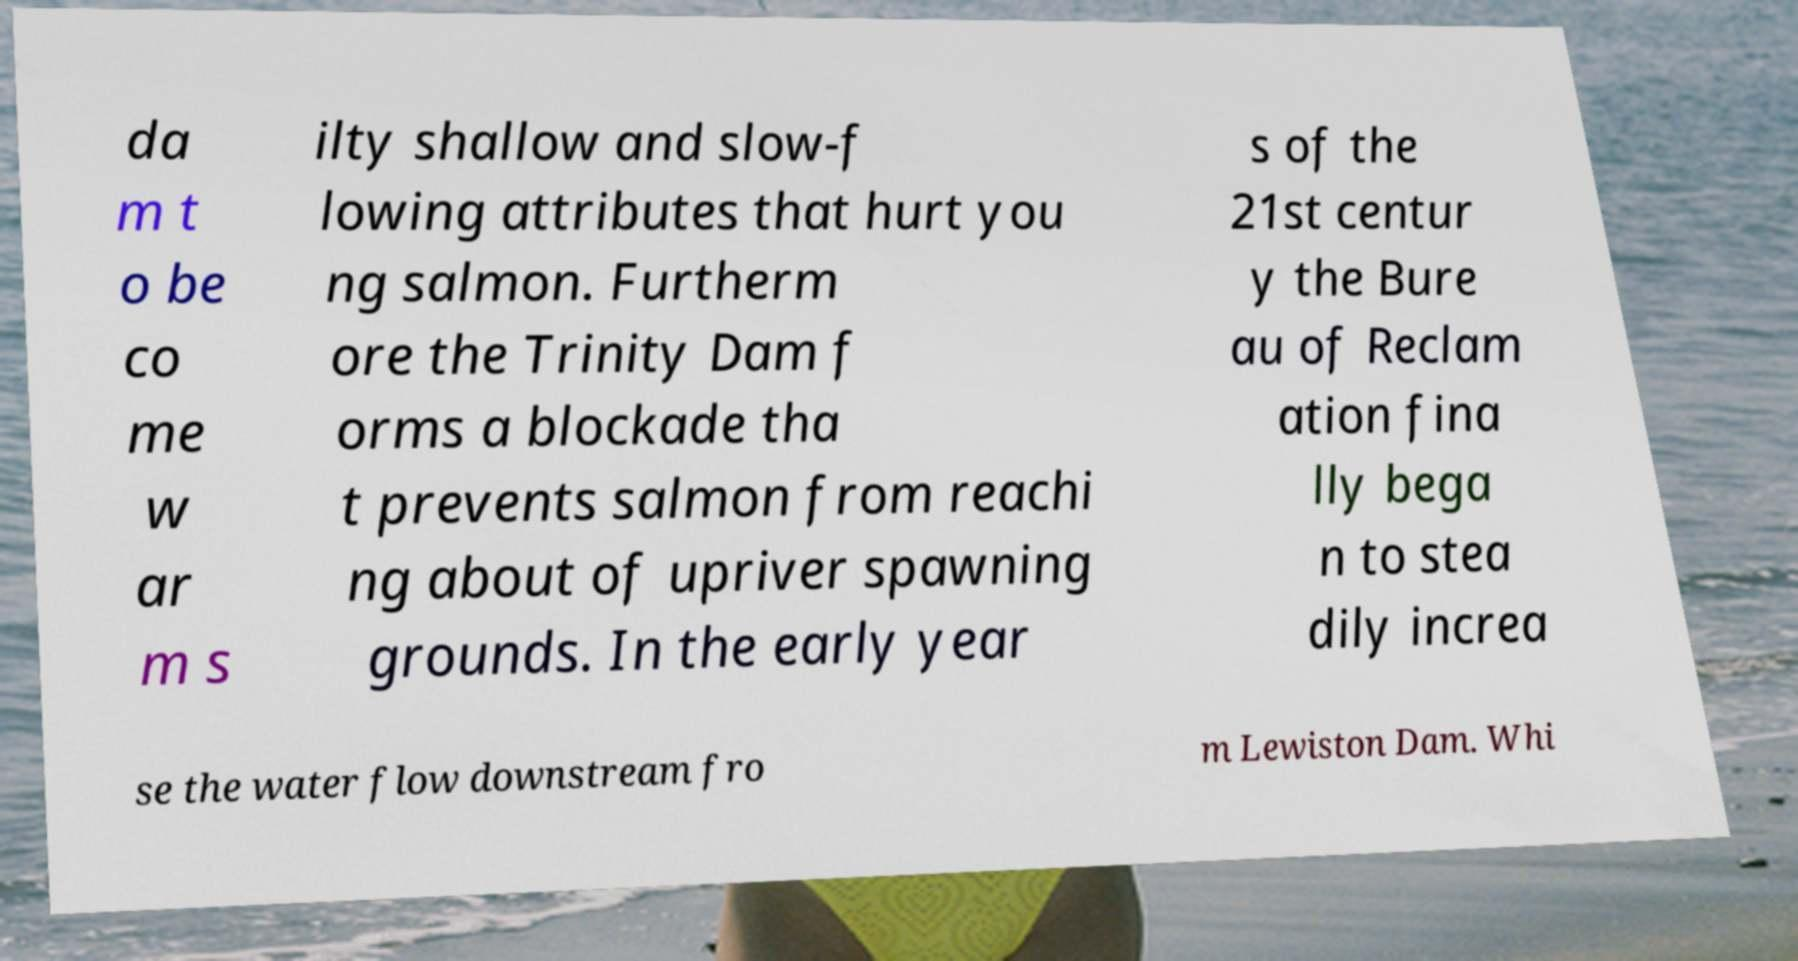There's text embedded in this image that I need extracted. Can you transcribe it verbatim? da m t o be co me w ar m s ilty shallow and slow-f lowing attributes that hurt you ng salmon. Furtherm ore the Trinity Dam f orms a blockade tha t prevents salmon from reachi ng about of upriver spawning grounds. In the early year s of the 21st centur y the Bure au of Reclam ation fina lly bega n to stea dily increa se the water flow downstream fro m Lewiston Dam. Whi 